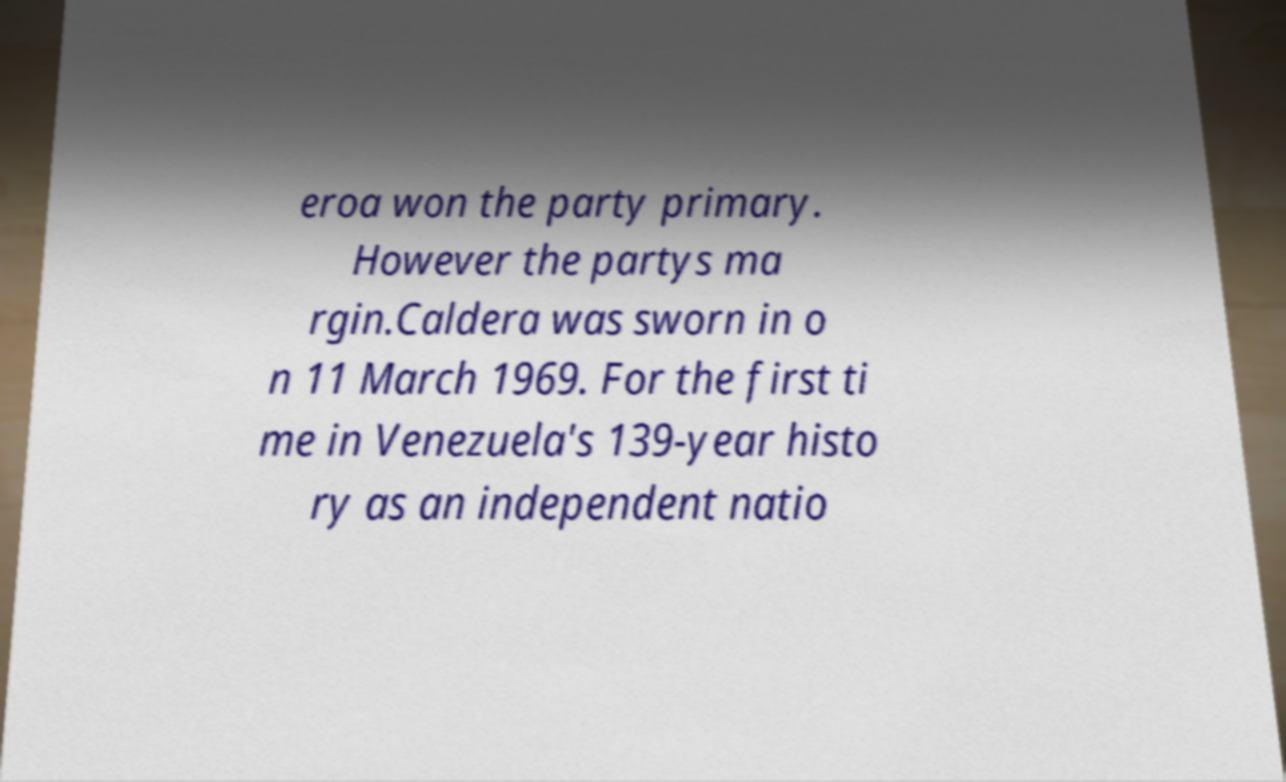Can you accurately transcribe the text from the provided image for me? eroa won the party primary. However the partys ma rgin.Caldera was sworn in o n 11 March 1969. For the first ti me in Venezuela's 139-year histo ry as an independent natio 